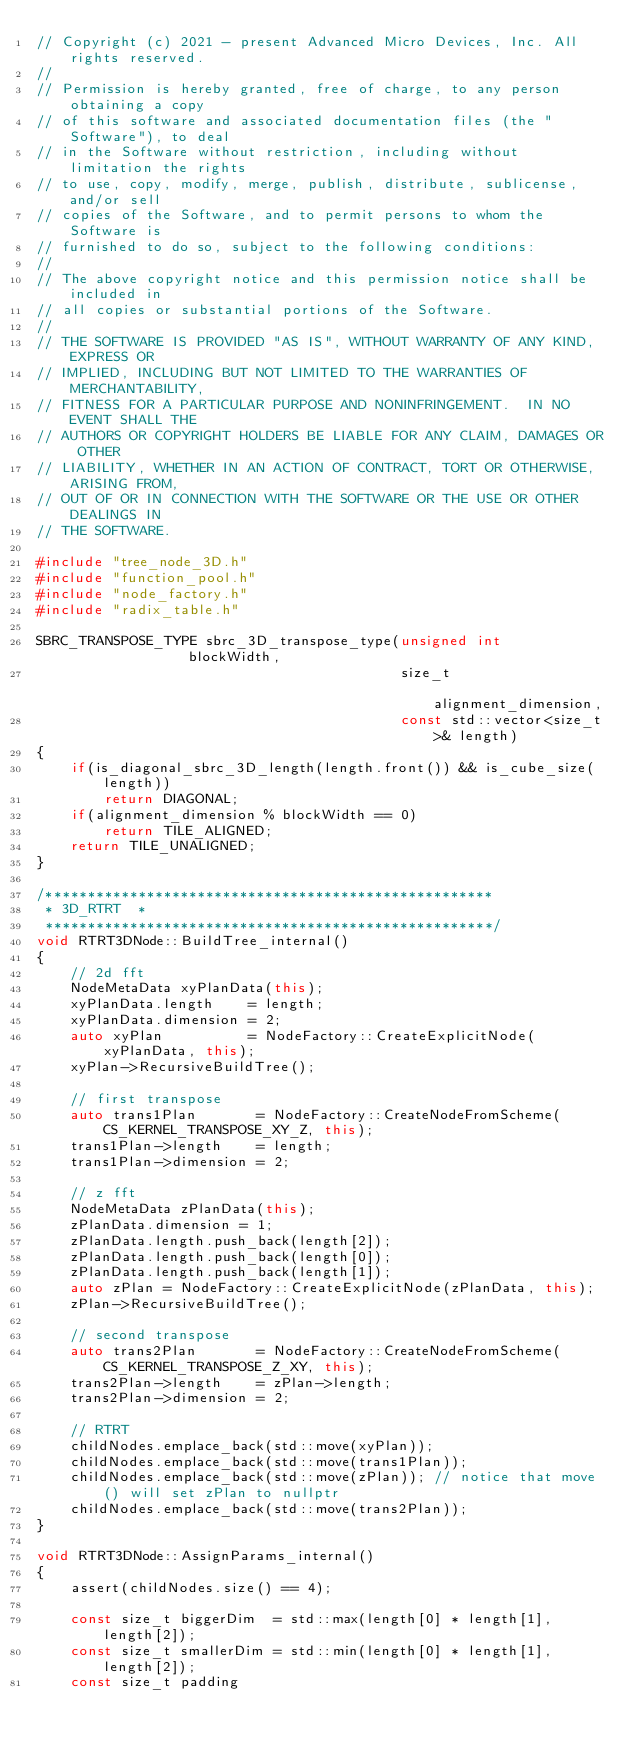<code> <loc_0><loc_0><loc_500><loc_500><_C++_>// Copyright (c) 2021 - present Advanced Micro Devices, Inc. All rights reserved.
//
// Permission is hereby granted, free of charge, to any person obtaining a copy
// of this software and associated documentation files (the "Software"), to deal
// in the Software without restriction, including without limitation the rights
// to use, copy, modify, merge, publish, distribute, sublicense, and/or sell
// copies of the Software, and to permit persons to whom the Software is
// furnished to do so, subject to the following conditions:
//
// The above copyright notice and this permission notice shall be included in
// all copies or substantial portions of the Software.
//
// THE SOFTWARE IS PROVIDED "AS IS", WITHOUT WARRANTY OF ANY KIND, EXPRESS OR
// IMPLIED, INCLUDING BUT NOT LIMITED TO THE WARRANTIES OF MERCHANTABILITY,
// FITNESS FOR A PARTICULAR PURPOSE AND NONINFRINGEMENT.  IN NO EVENT SHALL THE
// AUTHORS OR COPYRIGHT HOLDERS BE LIABLE FOR ANY CLAIM, DAMAGES OR OTHER
// LIABILITY, WHETHER IN AN ACTION OF CONTRACT, TORT OR OTHERWISE, ARISING FROM,
// OUT OF OR IN CONNECTION WITH THE SOFTWARE OR THE USE OR OTHER DEALINGS IN
// THE SOFTWARE.

#include "tree_node_3D.h"
#include "function_pool.h"
#include "node_factory.h"
#include "radix_table.h"

SBRC_TRANSPOSE_TYPE sbrc_3D_transpose_type(unsigned int               blockWidth,
                                           size_t                     alignment_dimension,
                                           const std::vector<size_t>& length)
{
    if(is_diagonal_sbrc_3D_length(length.front()) && is_cube_size(length))
        return DIAGONAL;
    if(alignment_dimension % blockWidth == 0)
        return TILE_ALIGNED;
    return TILE_UNALIGNED;
}

/*****************************************************
 * 3D_RTRT  *
 *****************************************************/
void RTRT3DNode::BuildTree_internal()
{
    // 2d fft
    NodeMetaData xyPlanData(this);
    xyPlanData.length    = length;
    xyPlanData.dimension = 2;
    auto xyPlan          = NodeFactory::CreateExplicitNode(xyPlanData, this);
    xyPlan->RecursiveBuildTree();

    // first transpose
    auto trans1Plan       = NodeFactory::CreateNodeFromScheme(CS_KERNEL_TRANSPOSE_XY_Z, this);
    trans1Plan->length    = length;
    trans1Plan->dimension = 2;

    // z fft
    NodeMetaData zPlanData(this);
    zPlanData.dimension = 1;
    zPlanData.length.push_back(length[2]);
    zPlanData.length.push_back(length[0]);
    zPlanData.length.push_back(length[1]);
    auto zPlan = NodeFactory::CreateExplicitNode(zPlanData, this);
    zPlan->RecursiveBuildTree();

    // second transpose
    auto trans2Plan       = NodeFactory::CreateNodeFromScheme(CS_KERNEL_TRANSPOSE_Z_XY, this);
    trans2Plan->length    = zPlan->length;
    trans2Plan->dimension = 2;

    // RTRT
    childNodes.emplace_back(std::move(xyPlan));
    childNodes.emplace_back(std::move(trans1Plan));
    childNodes.emplace_back(std::move(zPlan)); // notice that move() will set zPlan to nullptr
    childNodes.emplace_back(std::move(trans2Plan));
}

void RTRT3DNode::AssignParams_internal()
{
    assert(childNodes.size() == 4);

    const size_t biggerDim  = std::max(length[0] * length[1], length[2]);
    const size_t smallerDim = std::min(length[0] * length[1], length[2]);
    const size_t padding</code> 